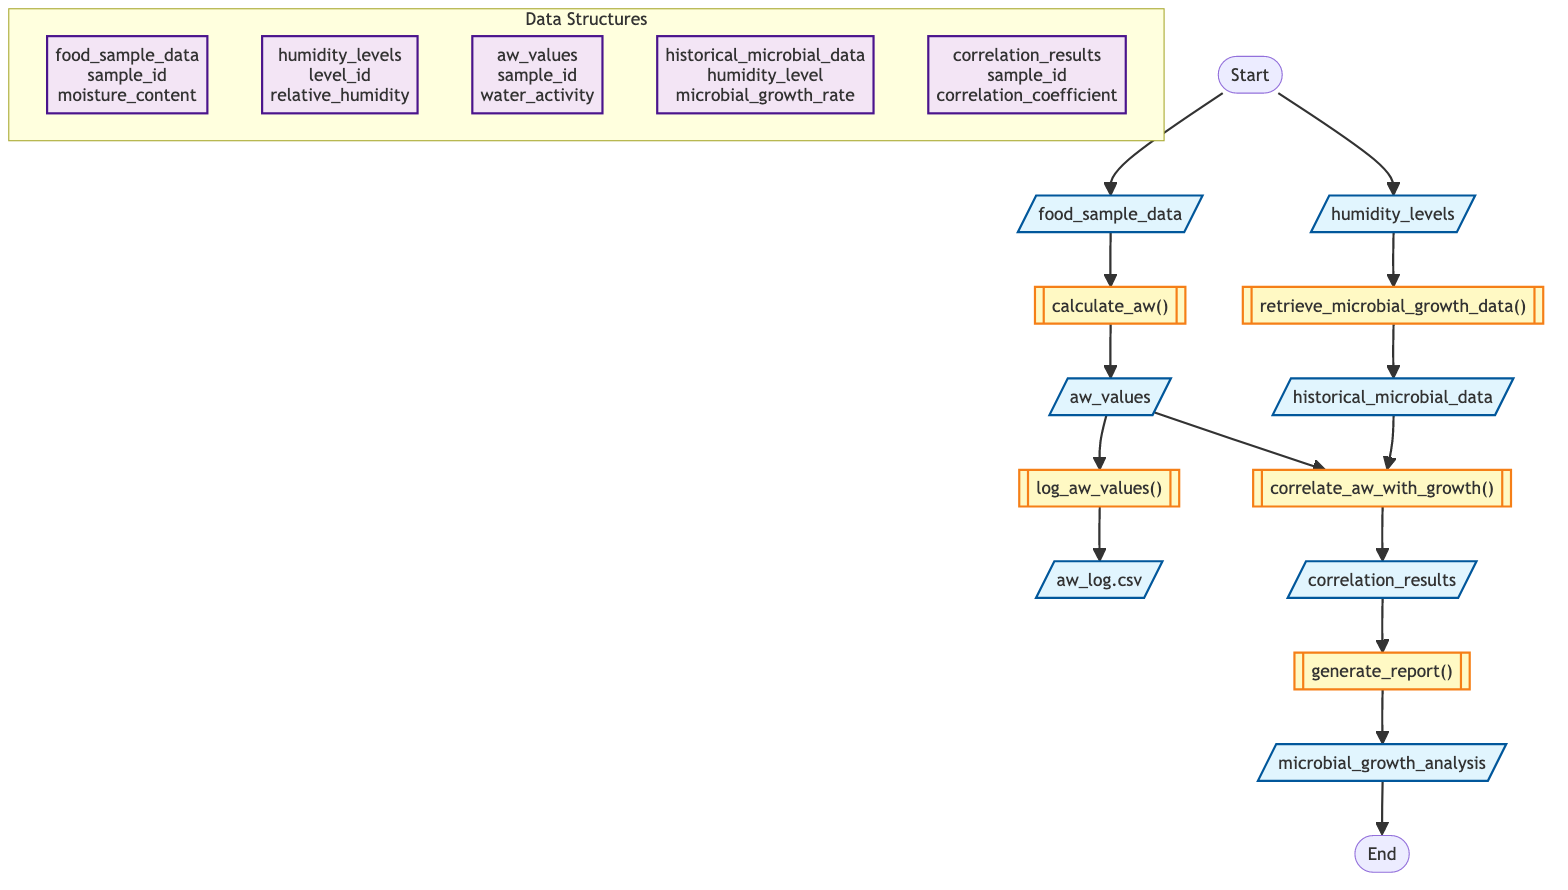What are the inputs for the function analyze_water_activity? The inputs for the function are listed in the first part of the flowchart; they are food_sample_data and humidity_levels.
Answer: food_sample_data, humidity_levels What is the output of the function analyze_water_activity? The output of the function is specified clearly at the end of the flowchart; it is microbial_growth_analysis.
Answer: microbial_growth_analysis How many steps are there in the function analyze_water_activity? By examining the flowchart, we can count the steps involved in the process. There are five steps in total: calculate_aw, log_aw_values, retrieve_microbial_growth_data, correlate_aw_with_growth, and generate_report.
Answer: 5 Which step directly follows the logging of water activity values? According to the flowchart, after the log_aw_values step and its output (aw_log.csv), the next step is retrieving historical microbial growth data, which is represented as retrieve_microbial_growth_data.
Answer: retrieve_microbial_growth_data What data structure contains humidity levels? The data structure that contains humidity levels is explicitly labeled in the subgraph section of the flowchart; it is humidity_levels.
Answer: humidity_levels What is the relationship between aw_values and historical_microbial_data? In the flowchart, the aw_values (output of calculate_aw) and historical_microbial_data (output of retrieve_microbial_growth_data) are inputs for the next step, correlate_aw_with_growth, showing a direct relationship as inputs to that function.
Answer: Inputs to correlate_aw_with_growth What does the function log_aw_values() produce as an output? The output of the function log_aw_values() is illustrated in the flowchart, which indicates it produces a file named aw_log.csv as an output.
Answer: aw_log.csv What is the main purpose of the step generate_report()? The purpose of the step generate_report() can be understood from its output; it aims to generate a comprehensive report of microbial activity versus water activity.
Answer: Generate a report of microbial activity vs water activity Which data structure contains the correlation coefficient results? The data structure that holds the correlation coefficient results is labeled as correlation_results in the flowchart.
Answer: correlation_results 